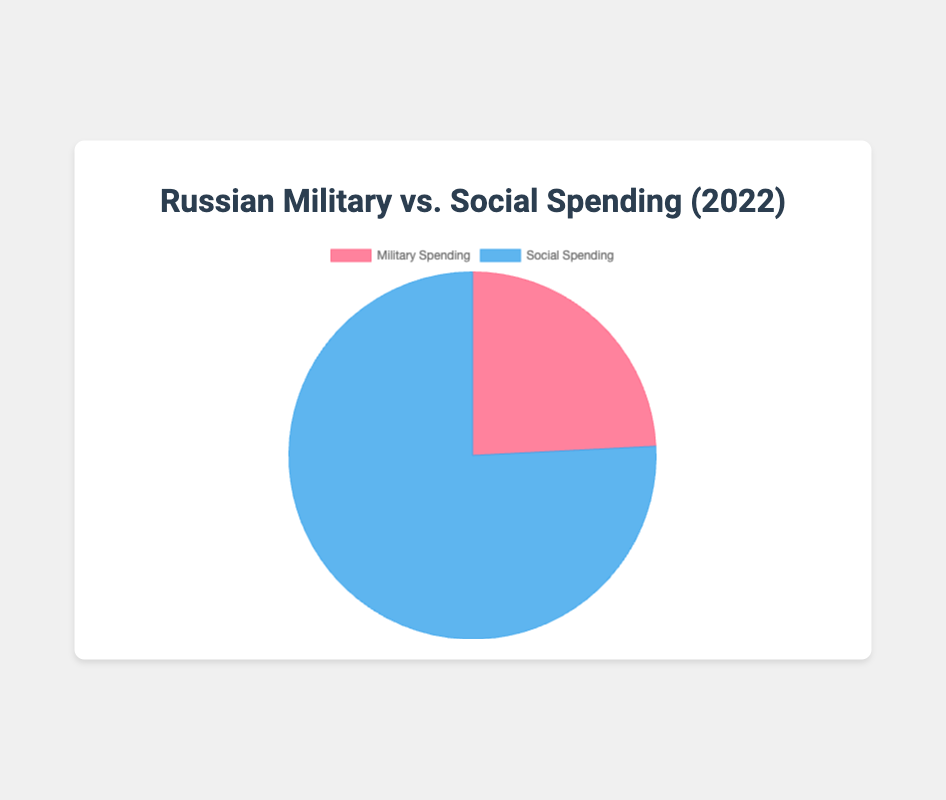What percentage of the total spending in 2022 is allocated to military expenses? The pie chart shows the percentage of military spending as 24.2%. This gives the proportion of the total budget that is allocated to military expenses.
Answer: 24.2% What percentage of the total spending in 2022 is allocated to social services? The pie chart shows the percentage of social spending as 75.8%. This indicates the proportion of the total budget that is allocated to social services.
Answer: 75.8% How does the percentage of military spending in 2022 compare to that of social spending? According to the pie chart, military spending accounts for 24.2% while social spending accounts for 75.8% of the total budget in 2022. Thus, social spending is significantly higher than military spending.
Answer: Social spending is higher What is the combined percentage of military and social spending in 2022? The pie chart only contains two categories: military spending (24.2%) and social spending (75.8%). Adding these two percentages yields 100%.
Answer: 100% What is the difference in percentage points between social spending and military spending in 2022? To find the difference, subtract the percentage of military spending (24.2%) from the percentage of social spending (75.8%). This equals to (75.8% - 24.2% = 51.6%).
Answer: 51.6% If the military spending were to increase by 5 percentage points, what would be the new percentage for social spending? If military spending increases by 5 percentage points, it becomes (24.2% + 5% = 29.2%). Since the total must be 100%, social spending will be (100% - 29.2% = 70.8%).
Answer: 70.8% 